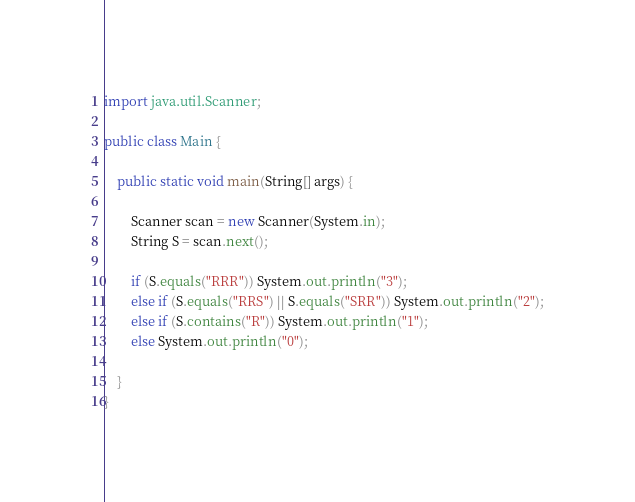Convert code to text. <code><loc_0><loc_0><loc_500><loc_500><_Java_>import java.util.Scanner;

public class Main {

	public static void main(String[] args) {

		Scanner scan = new Scanner(System.in);
		String S = scan.next();

		if (S.equals("RRR")) System.out.println("3");
		else if (S.equals("RRS") || S.equals("SRR")) System.out.println("2");
		else if (S.contains("R")) System.out.println("1");
		else System.out.println("0");

 	}
}</code> 